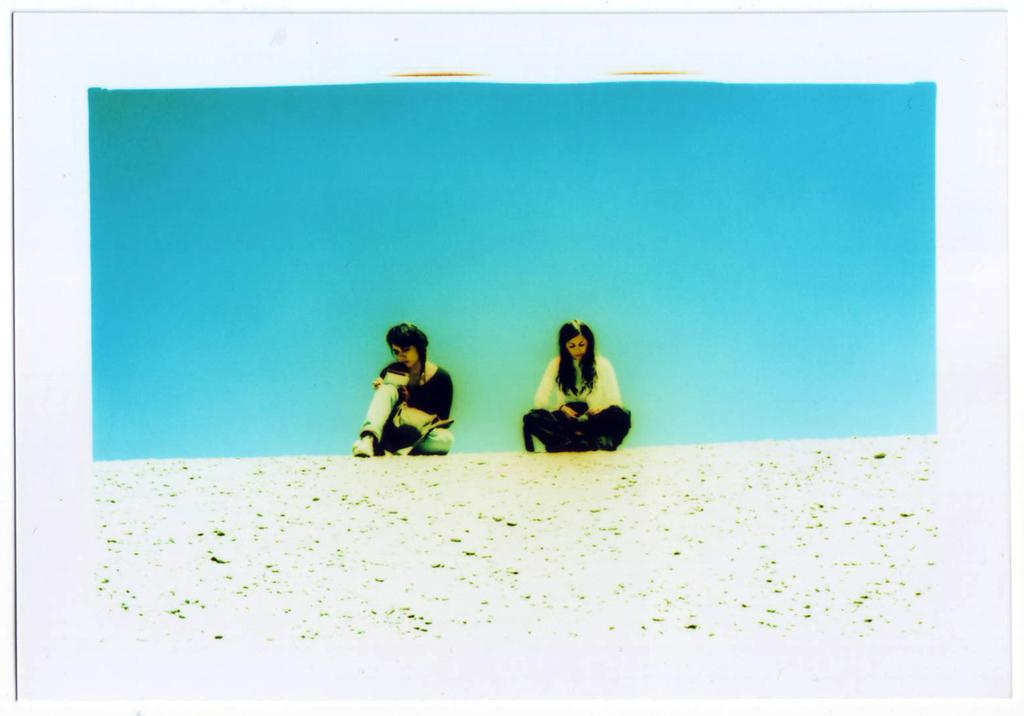How many people are in the image? There are two people in the middle of the image. What can be observed about the background of the image? The background color is blue. How many kittens are playing in the stream in the image? There are no kittens or streams present in the image; it features two people in the middle of the image with a blue background. 